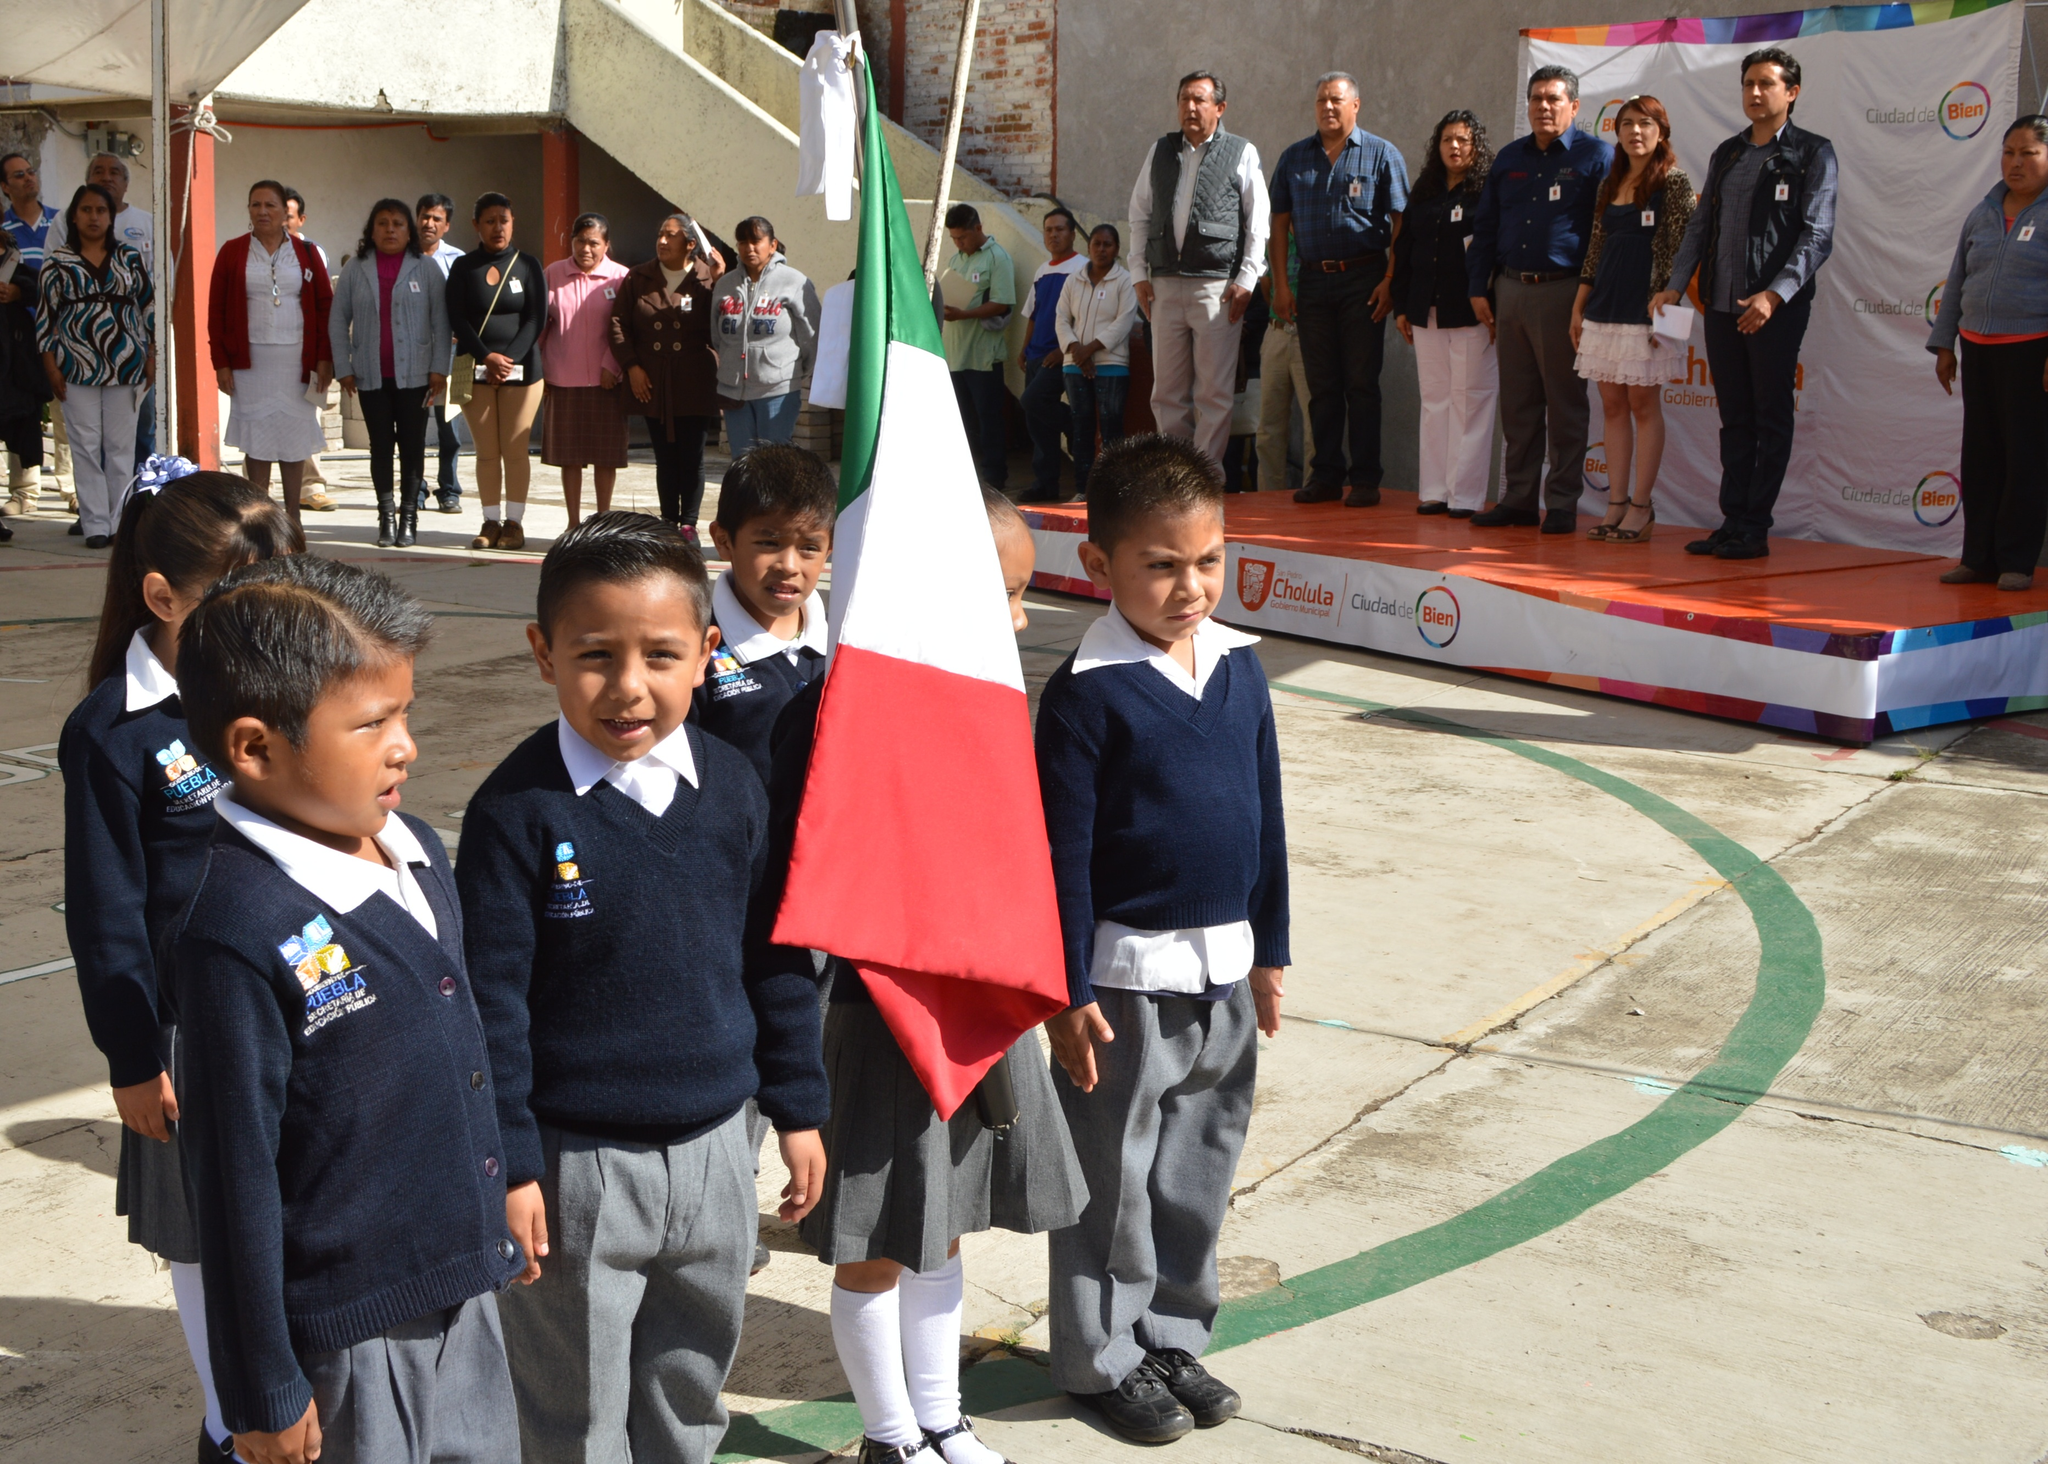In one or two sentences, can you explain what this image depicts? In this image I can see few children wearing blue, white and grey colored dress are standing and holding a flag which is green, white and red in color. In the background I can see the stage, few persons standing on the stage, a banner, few persons standing below the stage and the building. 